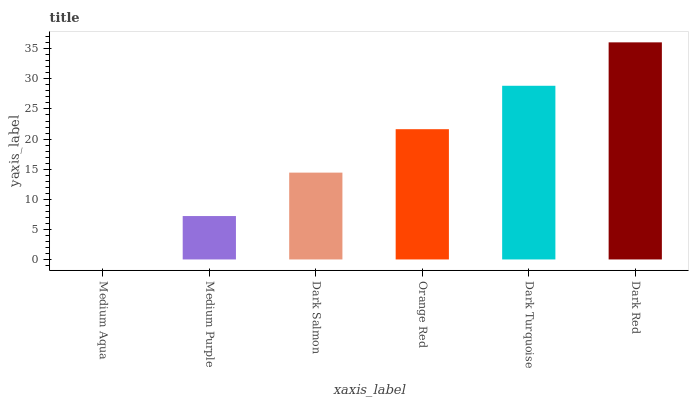Is Medium Aqua the minimum?
Answer yes or no. Yes. Is Dark Red the maximum?
Answer yes or no. Yes. Is Medium Purple the minimum?
Answer yes or no. No. Is Medium Purple the maximum?
Answer yes or no. No. Is Medium Purple greater than Medium Aqua?
Answer yes or no. Yes. Is Medium Aqua less than Medium Purple?
Answer yes or no. Yes. Is Medium Aqua greater than Medium Purple?
Answer yes or no. No. Is Medium Purple less than Medium Aqua?
Answer yes or no. No. Is Orange Red the high median?
Answer yes or no. Yes. Is Dark Salmon the low median?
Answer yes or no. Yes. Is Dark Turquoise the high median?
Answer yes or no. No. Is Medium Aqua the low median?
Answer yes or no. No. 